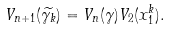<formula> <loc_0><loc_0><loc_500><loc_500>V _ { n + 1 } ( \widetilde { \gamma _ { k } } ) = V _ { n } ( \gamma ) V _ { 2 } ( x _ { 1 } ^ { k } ) .</formula> 